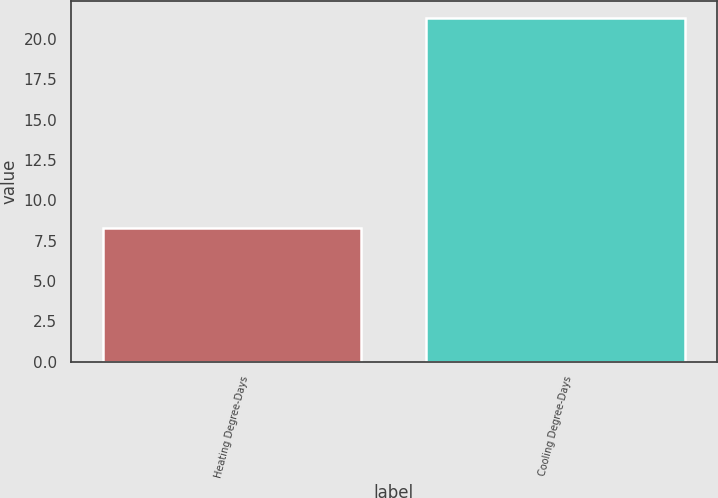Convert chart. <chart><loc_0><loc_0><loc_500><loc_500><bar_chart><fcel>Heating Degree-Days<fcel>Cooling Degree-Days<nl><fcel>8.3<fcel>21.3<nl></chart> 